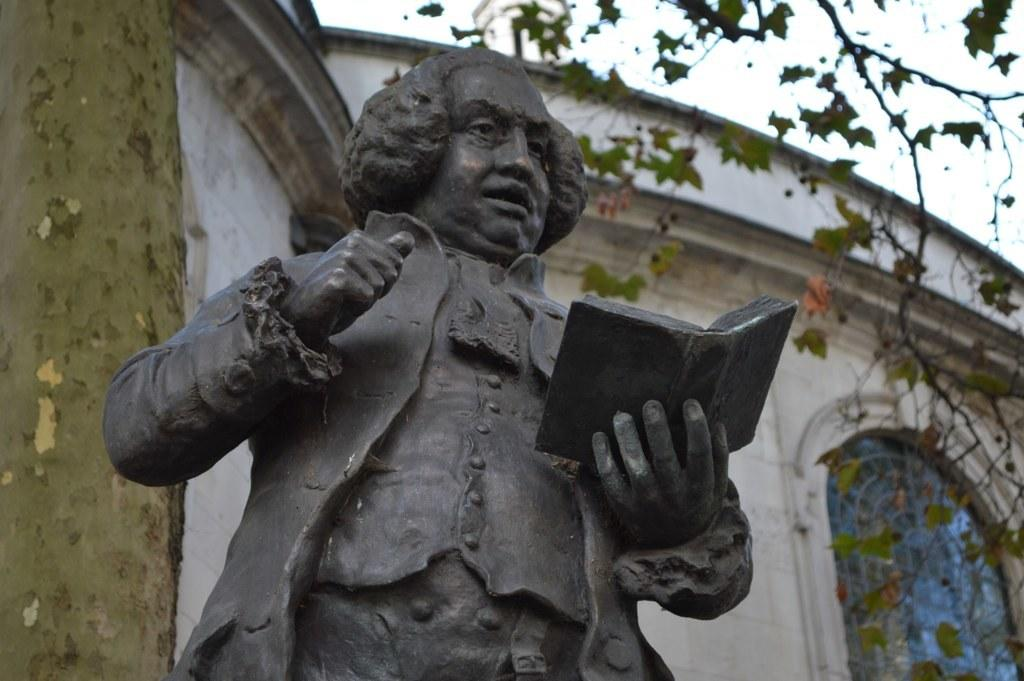What is the main subject in the image? There is a statue in the image. Can you describe the statue? The statue is of a man. What is the man holding in the statue? The man is holding a book. Where is the statue located in the image? The statue is in the foreground of the image. What type of match is the man playing in the image? There is no match or any sporting activity depicted in the image; it features a statue of a man holding a book. 